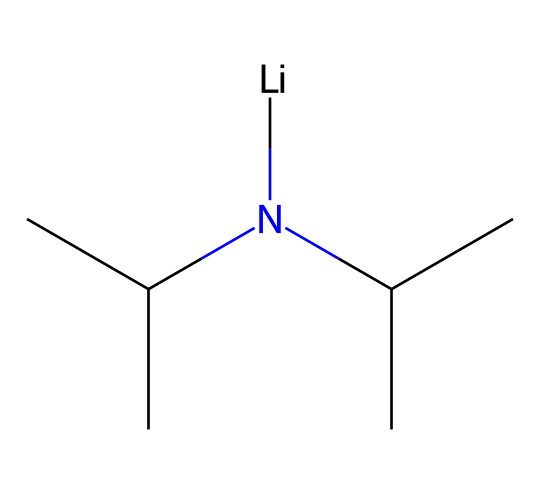What is the central metal atom in lithium diisopropylamide? The SMILES notation indicates the presence of lithium, which is the central metal atom in this compound, as it appears prominently in the notation.
Answer: lithium How many carbon atoms are present in lithium diisopropylamide? By analyzing the SMILES formula, we can count the instances of 'C' which represent carbon atoms. There are a total of 6 carbon atoms in the compound.
Answer: 6 What functional group is present in lithium diisopropylamide? The presence of the amide nitrogen (the 'N' in the SMILES) indicates that this compound contains an amine functional group, as it is bonded to carbon atoms.
Answer: amine What type of bond connects lithium to nitrogen in lithium diisopropylamide? In the structure of lithium diisopropylamide, lithium is connected to nitrogen through an ionic bond, which is characteristic of the bond between a metal and a nonmetal in superbases.
Answer: ionic How does the presence of isopropyl groups affect the polarity of lithium diisopropylamide? The isopropyl groups contribute to the steric hindrance and reduce the overall polarity of the molecule, making it more nonpolar. This can be inferred by considering the bulky nature of isopropyl groups affecting the dipole moment.
Answer: reduces polarity What property of lithium diisopropylamide categorizes it as a superbase? Lithium diisopropylamide is categorized as a superbase due to its ability to deprotonate weak acids, which relates to the strong basicity of the amine nitrogen connected to lithium.
Answer: strong basicity Can lithium diisopropylamide act as a nucleophile? Yes, lithium diisopropylamide can act as a nucleophile because the nitrogen atom has a lone pair that can donate electrons, participating in nucleophilic reactions.
Answer: yes 